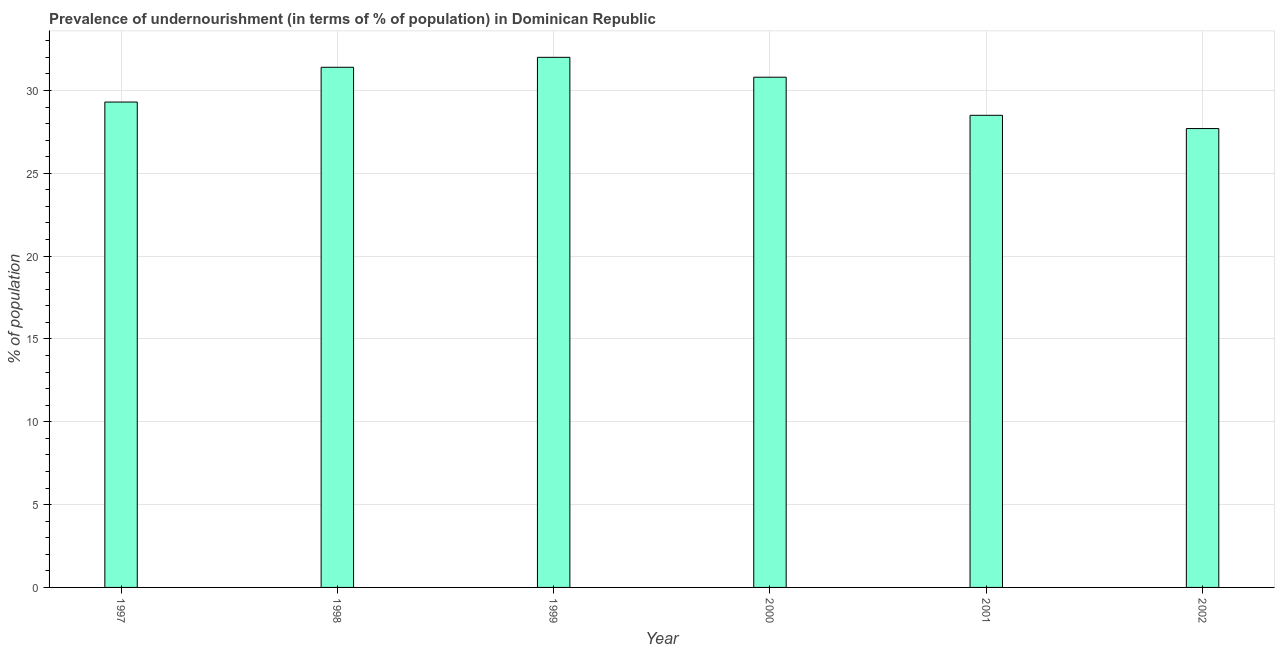Does the graph contain grids?
Provide a short and direct response. Yes. What is the title of the graph?
Offer a very short reply. Prevalence of undernourishment (in terms of % of population) in Dominican Republic. What is the label or title of the X-axis?
Your answer should be very brief. Year. What is the label or title of the Y-axis?
Your answer should be compact. % of population. What is the percentage of undernourished population in 2002?
Provide a short and direct response. 27.7. Across all years, what is the maximum percentage of undernourished population?
Offer a terse response. 32. Across all years, what is the minimum percentage of undernourished population?
Keep it short and to the point. 27.7. In which year was the percentage of undernourished population maximum?
Provide a succinct answer. 1999. What is the sum of the percentage of undernourished population?
Your answer should be compact. 179.7. What is the average percentage of undernourished population per year?
Provide a succinct answer. 29.95. What is the median percentage of undernourished population?
Provide a succinct answer. 30.05. In how many years, is the percentage of undernourished population greater than 31 %?
Offer a terse response. 2. Do a majority of the years between 2002 and 2001 (inclusive) have percentage of undernourished population greater than 12 %?
Ensure brevity in your answer.  No. What is the ratio of the percentage of undernourished population in 1998 to that in 2000?
Your answer should be compact. 1.02. Is the percentage of undernourished population in 2000 less than that in 2002?
Your answer should be very brief. No. Is the difference between the percentage of undernourished population in 1997 and 2001 greater than the difference between any two years?
Keep it short and to the point. No. What is the difference between the highest and the second highest percentage of undernourished population?
Your answer should be compact. 0.6. How many bars are there?
Give a very brief answer. 6. Are all the bars in the graph horizontal?
Offer a terse response. No. What is the difference between two consecutive major ticks on the Y-axis?
Ensure brevity in your answer.  5. Are the values on the major ticks of Y-axis written in scientific E-notation?
Give a very brief answer. No. What is the % of population in 1997?
Your response must be concise. 29.3. What is the % of population of 1998?
Offer a very short reply. 31.4. What is the % of population of 2000?
Ensure brevity in your answer.  30.8. What is the % of population in 2002?
Provide a succinct answer. 27.7. What is the difference between the % of population in 1997 and 1999?
Your response must be concise. -2.7. What is the difference between the % of population in 1997 and 2000?
Your response must be concise. -1.5. What is the difference between the % of population in 1997 and 2001?
Your response must be concise. 0.8. What is the difference between the % of population in 1997 and 2002?
Give a very brief answer. 1.6. What is the difference between the % of population in 1998 and 1999?
Ensure brevity in your answer.  -0.6. What is the difference between the % of population in 1998 and 2000?
Your answer should be very brief. 0.6. What is the difference between the % of population in 1998 and 2001?
Offer a terse response. 2.9. What is the difference between the % of population in 1998 and 2002?
Provide a succinct answer. 3.7. What is the difference between the % of population in 1999 and 2000?
Offer a very short reply. 1.2. What is the difference between the % of population in 1999 and 2001?
Offer a terse response. 3.5. What is the difference between the % of population in 1999 and 2002?
Provide a succinct answer. 4.3. What is the difference between the % of population in 2000 and 2001?
Keep it short and to the point. 2.3. What is the difference between the % of population in 2000 and 2002?
Ensure brevity in your answer.  3.1. What is the difference between the % of population in 2001 and 2002?
Make the answer very short. 0.8. What is the ratio of the % of population in 1997 to that in 1998?
Provide a short and direct response. 0.93. What is the ratio of the % of population in 1997 to that in 1999?
Offer a very short reply. 0.92. What is the ratio of the % of population in 1997 to that in 2000?
Your answer should be compact. 0.95. What is the ratio of the % of population in 1997 to that in 2001?
Give a very brief answer. 1.03. What is the ratio of the % of population in 1997 to that in 2002?
Provide a succinct answer. 1.06. What is the ratio of the % of population in 1998 to that in 1999?
Keep it short and to the point. 0.98. What is the ratio of the % of population in 1998 to that in 2001?
Your response must be concise. 1.1. What is the ratio of the % of population in 1998 to that in 2002?
Provide a succinct answer. 1.13. What is the ratio of the % of population in 1999 to that in 2000?
Provide a succinct answer. 1.04. What is the ratio of the % of population in 1999 to that in 2001?
Your answer should be very brief. 1.12. What is the ratio of the % of population in 1999 to that in 2002?
Give a very brief answer. 1.16. What is the ratio of the % of population in 2000 to that in 2001?
Give a very brief answer. 1.08. What is the ratio of the % of population in 2000 to that in 2002?
Ensure brevity in your answer.  1.11. What is the ratio of the % of population in 2001 to that in 2002?
Offer a terse response. 1.03. 